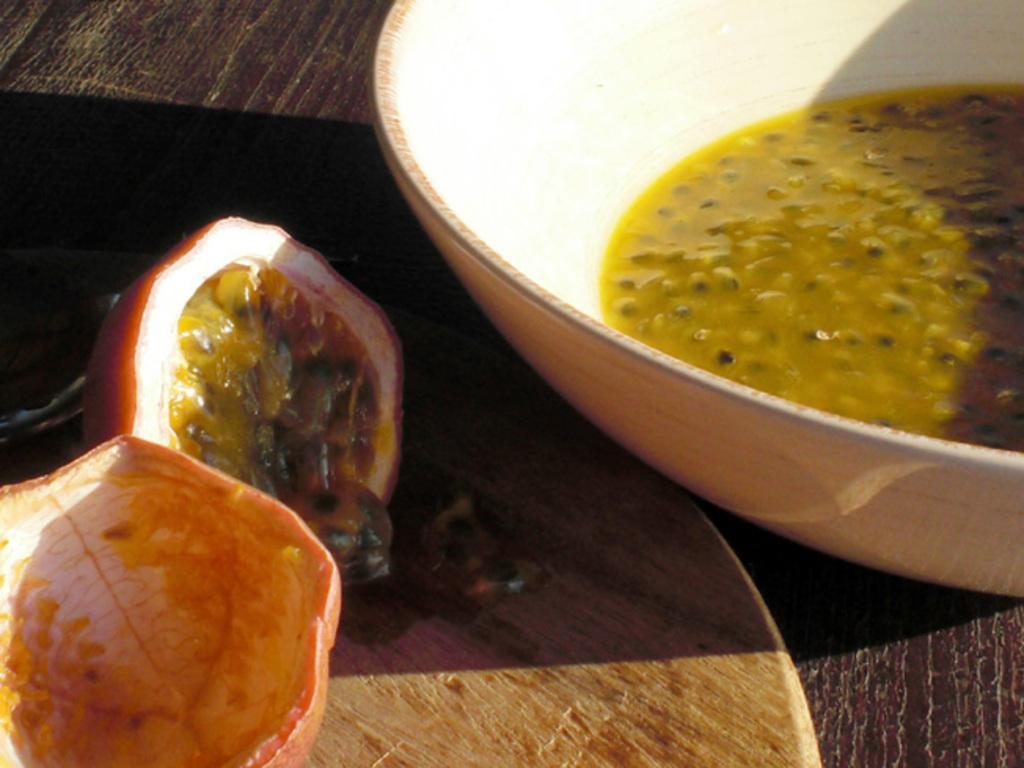Please provide a concise description of this image. In this picture there is a bowl in the top right side of the image, which contains food item in it and there is another food item in the bottom left side of the image, which are placed on a table. 